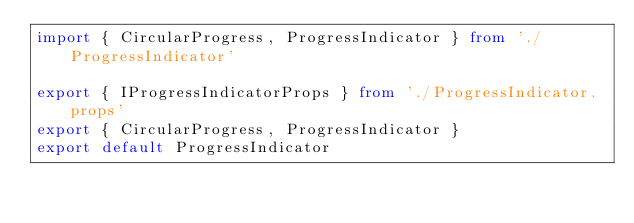<code> <loc_0><loc_0><loc_500><loc_500><_TypeScript_>import { CircularProgress, ProgressIndicator } from './ProgressIndicator'

export { IProgressIndicatorProps } from './ProgressIndicator.props'
export { CircularProgress, ProgressIndicator }
export default ProgressIndicator
</code> 